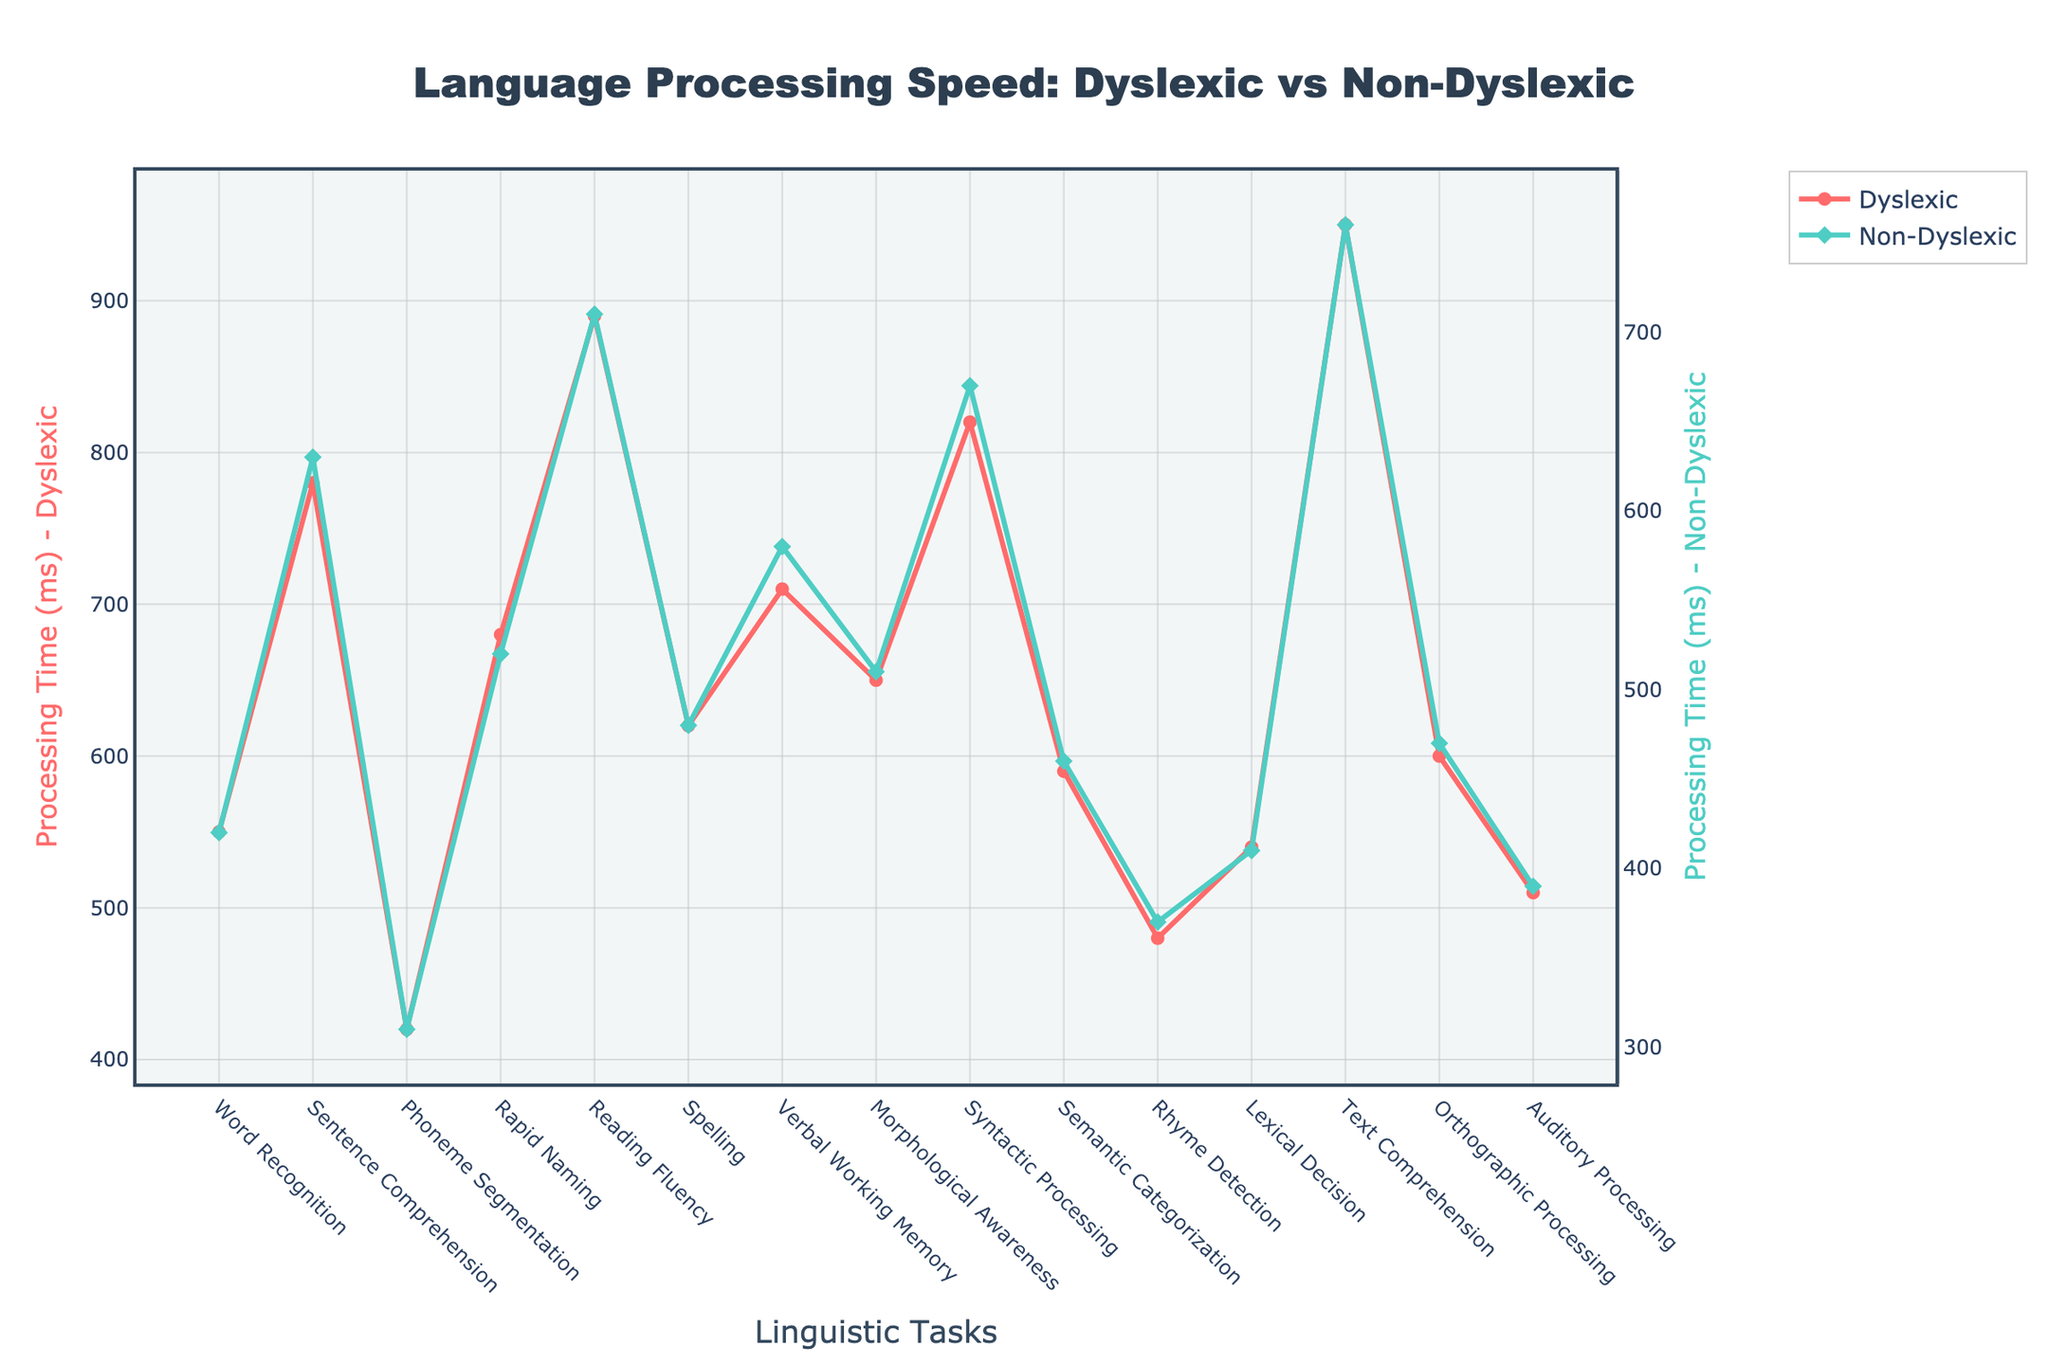What is the processing time for the "Rapid Naming" task for dyslexic individuals, and how does it compare to non-dyslexic individuals? The processing time for the "Rapid Naming" task can be identified on the y-axis by following the "Rapid Naming" label on the x-axis. The dyslexic individuals have a processing time of 680 ms, while non-dyslexic individuals have 520 ms. The dyslexic processing time is 160 ms higher.
Answer: Dyslexic: 680 ms, Non-Dyslexic: 520 ms, Dyslexic is 160 ms higher Which task shows the largest difference in processing time between dyslexic and non-dyslexic individuals, and what is this difference? We need to subtract non-dyslexic times from dyslexic times for each task and find the maximum difference. "Text Comprehension" has the largest difference, calculated as 950 ms - 760 ms = 190 ms.
Answer: Text Comprehension, 190 ms Which task shows the smallest difference in processing time between dyslexic and non-dyslexic individuals? By comparing the differences (dyslexic - non-dyslexic) across all tasks, "Auditory Processing" has the smallest difference with 510 ms - 390 ms = 120 ms.
Answer: Auditory Processing, 120 ms What is the average processing time across all tasks for non-dyslexic individuals? To find the average processing time, sum up all non-dyslexic times and divide by the number of tasks. The total sum is (420 + 630 + 310 + 520 + 710 + 480 + 580 + 510 + 670 + 460 + 370 + 410 + 760 + 470 + 390) = 7690 ms, and there are 15 tasks. The average is 7690 ms / 15 ≈ 512.7 ms.
Answer: ~512.7 ms Which linguistic task has the longest processing time for dyslexic individuals? Scan through the tasks and identify the maximum value for dyslexic individuals. "Text Comprehension" has the longest processing time of 950 ms.
Answer: Text Comprehension, 950 ms How much faster is the "Phoneme Segmentation" task for non-dyslexic compared to dyslexic individuals in percentage? Calculate the difference and then convert it into a percentage. The difference is 420 ms - 310 ms = 110 ms. The percentage difference is (110 ms / 420 ms) * 100 ≈ 26.19%.
Answer: ~26.19% What tasks have processing times below 500 ms for dyslexic individuals? Identify tasks where the dyslexic processing time is less than 500 ms. The tasks are "Phoneme Segmentation" (420 ms) and "Rhyme Detection" (480 ms).
Answer: Phoneme Segmentation, Rhyme Detection Are there any tasks where non-dyslexic individuals have higher processing times than dyslexic individuals? Compare the processing times for each task. There are no tasks where non-dyslexic processing times are higher than dyslexic processing times.
Answer: No Which visual attributes differentiate the data for dyslexic and non-dyslexic individuals in the figure? The lines are differentiated by color and marker shape. Dyslexic data is represented with red lines and circle markers, while non-dyslexic data is represented with green lines and diamond markers.
Answer: Color and marker shape differentiation 